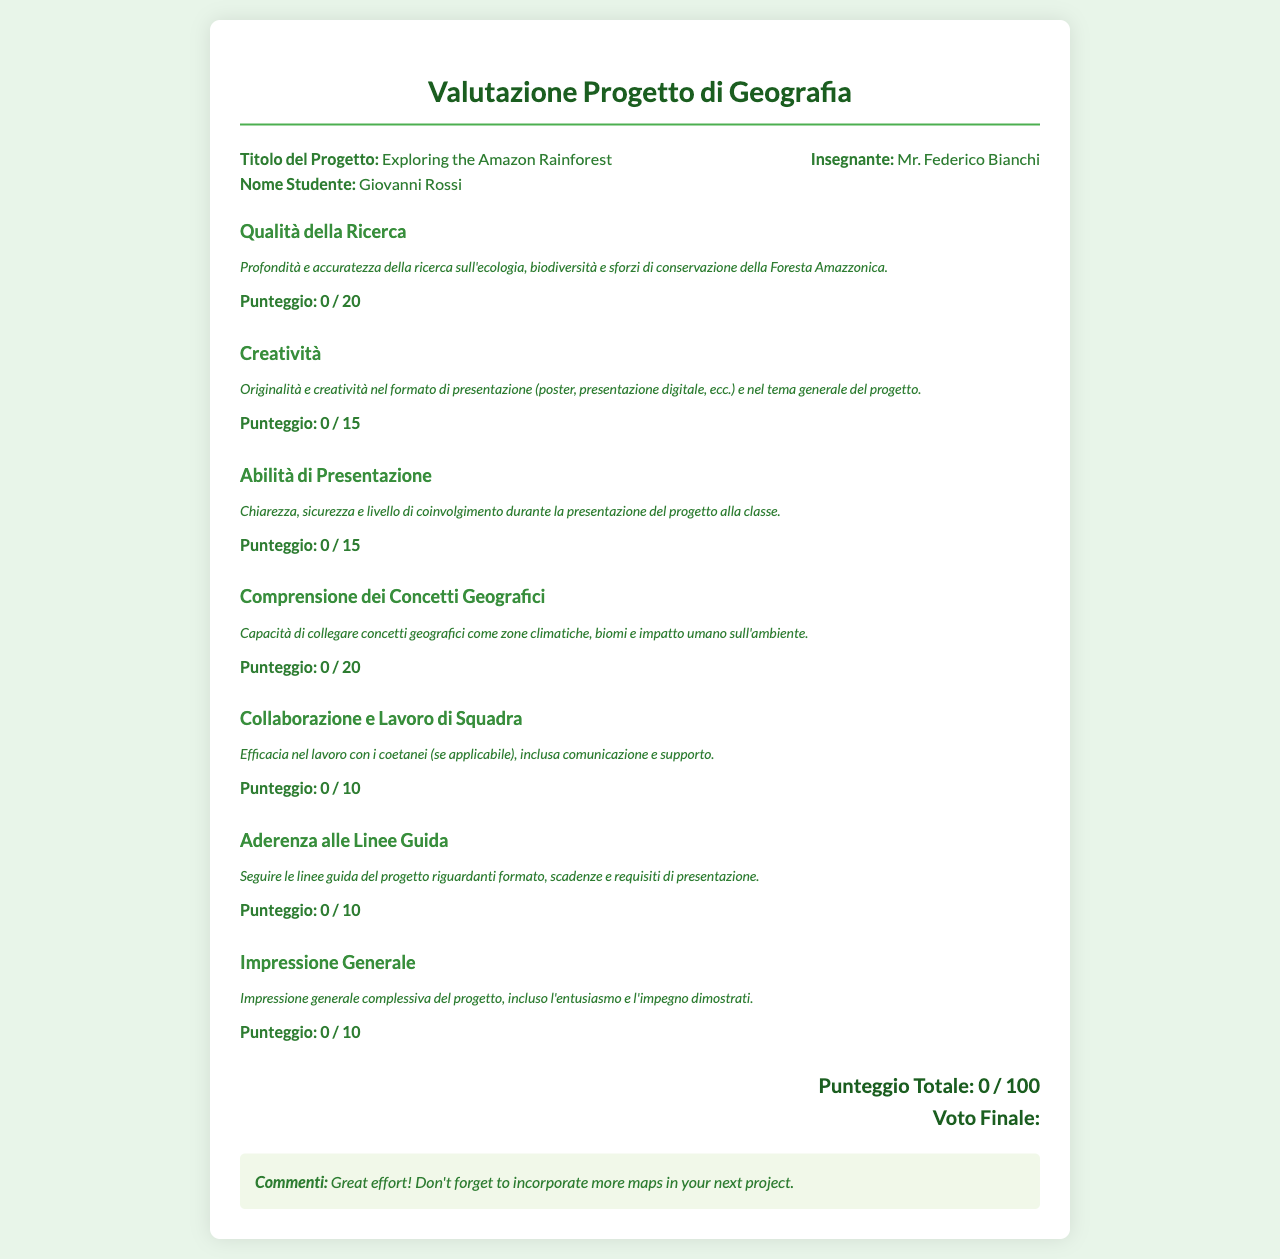Qual è il titolo del progetto? Il titolo del progetto è specificato nel documento e aiuta a identificare il lavoro presentato dallo studente.
Answer: Exploring the Amazon Rainforest Chi è il nome dello studente? Il nome dello studente è un'informazione chiave che identifica chi ha presentato il progetto.
Answer: Giovanni Rossi Chi è l'insegnante? L'insegnante è una figura fondamentale nel processo educativo e viene menzionato nel documento.
Answer: Mr. Federico Bianchi Qual è il punteggio massimo per la qualità della ricerca? Il punteggio massimo per ogni criterio di valutazione viene indicato chiaramente nel documento.
Answer: 20 Che commento è stato fornito? Il commento rappresenta il feedback dell'insegnante sul lavoro dello studente e aiuta a valutare il progetto.
Answer: Great effort! Don't forget to incorporate more maps in your next project Qual è il punteggio totale? Il punteggio totale è la somma dei punteggi per ciascun criterio di valutazione, ma in questo caso è zero, indicato nel documento.
Answer: 0 / 100 Qual è il punteggio massimo per la creatività? Il punteggio massimo per la creatività è specificato e contribuisce alla valutazione complessiva del progetto.
Answer: 15 Qual è l'argomento principale del progetto? L'argomento principale del progetto è evidenziato nel titolo, che delinea l'area di ricerca.
Answer: Foresta Amazzonica Che cosa valuta la sezione "Impressione Generale"? Questa sezione valuta come l'insegnante percepisce l'impegno e l'entusiasmo dello studente riguardo al progetto.
Answer: Entusiasmo e impegno 